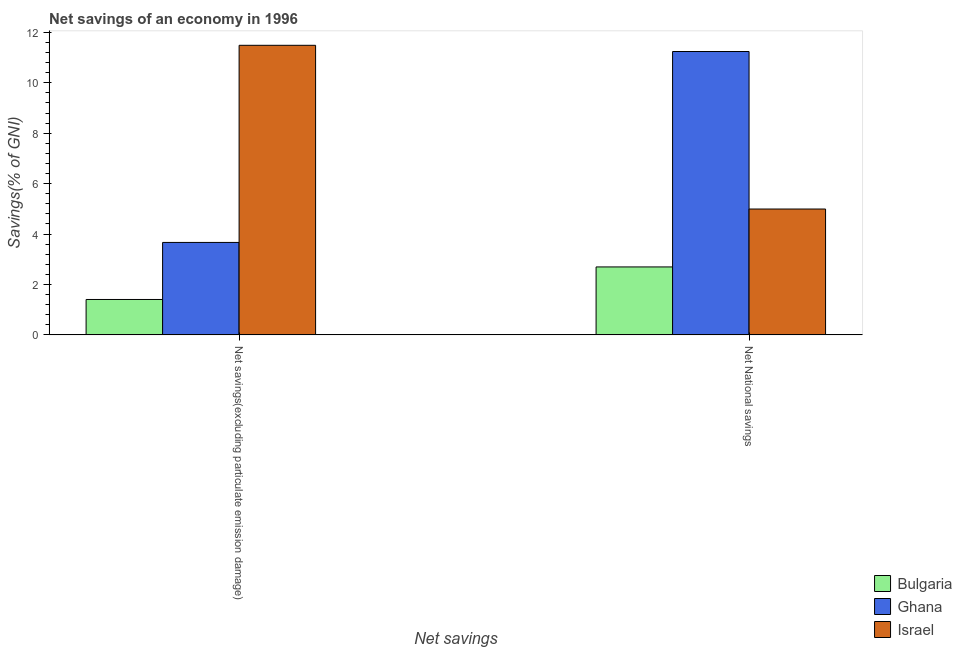Are the number of bars on each tick of the X-axis equal?
Your answer should be compact. Yes. How many bars are there on the 1st tick from the left?
Offer a very short reply. 3. How many bars are there on the 2nd tick from the right?
Your answer should be very brief. 3. What is the label of the 1st group of bars from the left?
Your answer should be compact. Net savings(excluding particulate emission damage). What is the net national savings in Ghana?
Your response must be concise. 11.24. Across all countries, what is the maximum net savings(excluding particulate emission damage)?
Give a very brief answer. 11.49. Across all countries, what is the minimum net savings(excluding particulate emission damage)?
Ensure brevity in your answer.  1.4. In which country was the net national savings maximum?
Your answer should be compact. Ghana. In which country was the net savings(excluding particulate emission damage) minimum?
Provide a succinct answer. Bulgaria. What is the total net savings(excluding particulate emission damage) in the graph?
Your response must be concise. 16.56. What is the difference between the net savings(excluding particulate emission damage) in Bulgaria and that in Ghana?
Offer a very short reply. -2.26. What is the difference between the net national savings in Ghana and the net savings(excluding particulate emission damage) in Bulgaria?
Provide a short and direct response. 9.84. What is the average net savings(excluding particulate emission damage) per country?
Provide a succinct answer. 5.52. What is the difference between the net national savings and net savings(excluding particulate emission damage) in Ghana?
Your response must be concise. 7.57. In how many countries, is the net savings(excluding particulate emission damage) greater than 5.6 %?
Make the answer very short. 1. What is the ratio of the net national savings in Ghana to that in Bulgaria?
Offer a very short reply. 4.17. Is the net savings(excluding particulate emission damage) in Israel less than that in Ghana?
Offer a terse response. No. In how many countries, is the net savings(excluding particulate emission damage) greater than the average net savings(excluding particulate emission damage) taken over all countries?
Offer a very short reply. 1. What does the 1st bar from the right in Net National savings represents?
Keep it short and to the point. Israel. How many bars are there?
Provide a succinct answer. 6. What is the difference between two consecutive major ticks on the Y-axis?
Your response must be concise. 2. Are the values on the major ticks of Y-axis written in scientific E-notation?
Give a very brief answer. No. Does the graph contain any zero values?
Keep it short and to the point. No. Where does the legend appear in the graph?
Offer a terse response. Bottom right. How many legend labels are there?
Provide a short and direct response. 3. How are the legend labels stacked?
Offer a terse response. Vertical. What is the title of the graph?
Provide a short and direct response. Net savings of an economy in 1996. What is the label or title of the X-axis?
Provide a short and direct response. Net savings. What is the label or title of the Y-axis?
Offer a terse response. Savings(% of GNI). What is the Savings(% of GNI) in Bulgaria in Net savings(excluding particulate emission damage)?
Keep it short and to the point. 1.4. What is the Savings(% of GNI) in Ghana in Net savings(excluding particulate emission damage)?
Your response must be concise. 3.67. What is the Savings(% of GNI) in Israel in Net savings(excluding particulate emission damage)?
Your answer should be compact. 11.49. What is the Savings(% of GNI) in Bulgaria in Net National savings?
Keep it short and to the point. 2.7. What is the Savings(% of GNI) of Ghana in Net National savings?
Ensure brevity in your answer.  11.24. What is the Savings(% of GNI) of Israel in Net National savings?
Your answer should be very brief. 4.99. Across all Net savings, what is the maximum Savings(% of GNI) of Bulgaria?
Offer a very short reply. 2.7. Across all Net savings, what is the maximum Savings(% of GNI) in Ghana?
Your answer should be compact. 11.24. Across all Net savings, what is the maximum Savings(% of GNI) in Israel?
Your answer should be very brief. 11.49. Across all Net savings, what is the minimum Savings(% of GNI) of Bulgaria?
Provide a succinct answer. 1.4. Across all Net savings, what is the minimum Savings(% of GNI) in Ghana?
Ensure brevity in your answer.  3.67. Across all Net savings, what is the minimum Savings(% of GNI) of Israel?
Ensure brevity in your answer.  4.99. What is the total Savings(% of GNI) in Bulgaria in the graph?
Provide a short and direct response. 4.1. What is the total Savings(% of GNI) of Ghana in the graph?
Offer a terse response. 14.91. What is the total Savings(% of GNI) in Israel in the graph?
Offer a very short reply. 16.48. What is the difference between the Savings(% of GNI) in Bulgaria in Net savings(excluding particulate emission damage) and that in Net National savings?
Your response must be concise. -1.29. What is the difference between the Savings(% of GNI) of Ghana in Net savings(excluding particulate emission damage) and that in Net National savings?
Provide a short and direct response. -7.57. What is the difference between the Savings(% of GNI) in Israel in Net savings(excluding particulate emission damage) and that in Net National savings?
Make the answer very short. 6.49. What is the difference between the Savings(% of GNI) in Bulgaria in Net savings(excluding particulate emission damage) and the Savings(% of GNI) in Ghana in Net National savings?
Your response must be concise. -9.84. What is the difference between the Savings(% of GNI) of Bulgaria in Net savings(excluding particulate emission damage) and the Savings(% of GNI) of Israel in Net National savings?
Offer a very short reply. -3.59. What is the difference between the Savings(% of GNI) in Ghana in Net savings(excluding particulate emission damage) and the Savings(% of GNI) in Israel in Net National savings?
Your response must be concise. -1.32. What is the average Savings(% of GNI) of Bulgaria per Net savings?
Provide a short and direct response. 2.05. What is the average Savings(% of GNI) in Ghana per Net savings?
Ensure brevity in your answer.  7.45. What is the average Savings(% of GNI) in Israel per Net savings?
Offer a very short reply. 8.24. What is the difference between the Savings(% of GNI) of Bulgaria and Savings(% of GNI) of Ghana in Net savings(excluding particulate emission damage)?
Your response must be concise. -2.26. What is the difference between the Savings(% of GNI) of Bulgaria and Savings(% of GNI) of Israel in Net savings(excluding particulate emission damage)?
Give a very brief answer. -10.08. What is the difference between the Savings(% of GNI) of Ghana and Savings(% of GNI) of Israel in Net savings(excluding particulate emission damage)?
Offer a terse response. -7.82. What is the difference between the Savings(% of GNI) in Bulgaria and Savings(% of GNI) in Ghana in Net National savings?
Give a very brief answer. -8.54. What is the difference between the Savings(% of GNI) in Bulgaria and Savings(% of GNI) in Israel in Net National savings?
Your answer should be very brief. -2.3. What is the difference between the Savings(% of GNI) in Ghana and Savings(% of GNI) in Israel in Net National savings?
Offer a very short reply. 6.25. What is the ratio of the Savings(% of GNI) in Bulgaria in Net savings(excluding particulate emission damage) to that in Net National savings?
Your answer should be compact. 0.52. What is the ratio of the Savings(% of GNI) of Ghana in Net savings(excluding particulate emission damage) to that in Net National savings?
Offer a very short reply. 0.33. What is the ratio of the Savings(% of GNI) of Israel in Net savings(excluding particulate emission damage) to that in Net National savings?
Provide a short and direct response. 2.3. What is the difference between the highest and the second highest Savings(% of GNI) in Bulgaria?
Your response must be concise. 1.29. What is the difference between the highest and the second highest Savings(% of GNI) in Ghana?
Offer a very short reply. 7.57. What is the difference between the highest and the second highest Savings(% of GNI) of Israel?
Offer a terse response. 6.49. What is the difference between the highest and the lowest Savings(% of GNI) in Bulgaria?
Offer a terse response. 1.29. What is the difference between the highest and the lowest Savings(% of GNI) of Ghana?
Ensure brevity in your answer.  7.57. What is the difference between the highest and the lowest Savings(% of GNI) in Israel?
Give a very brief answer. 6.49. 